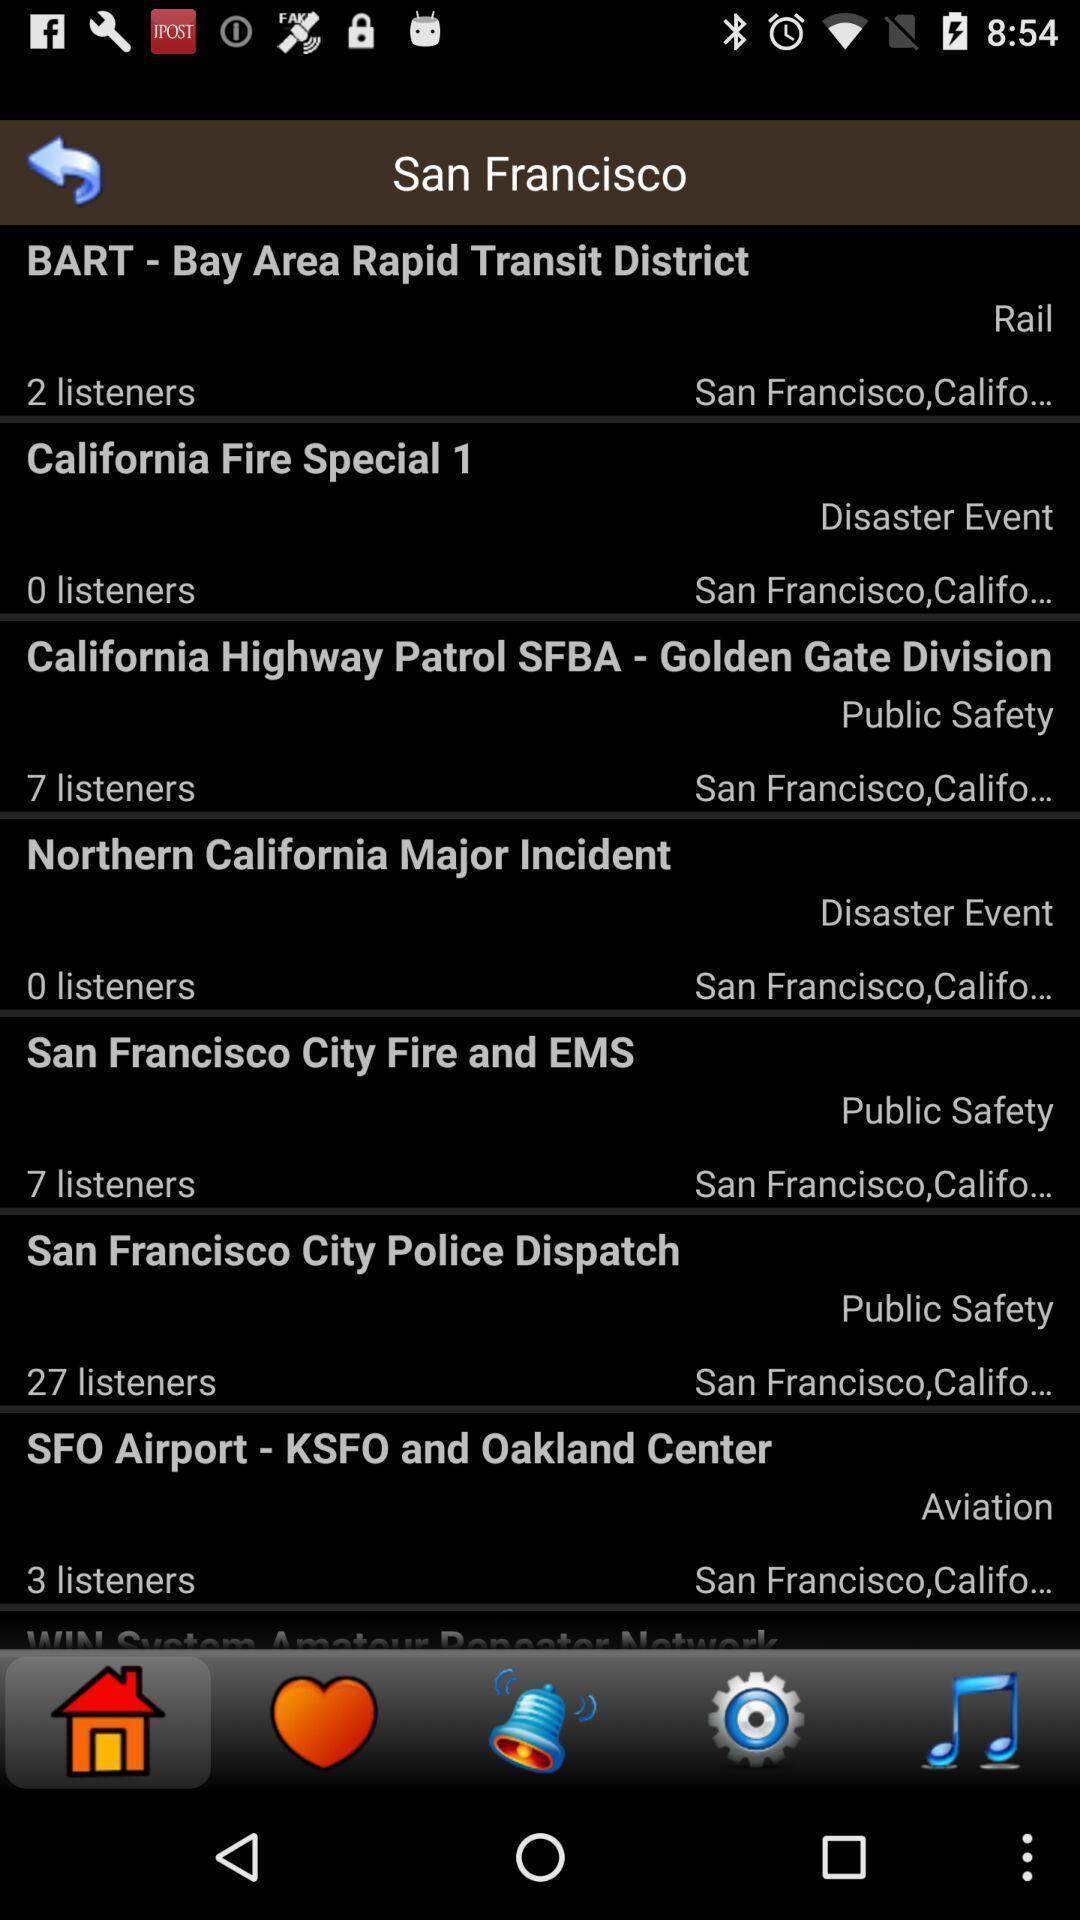Tell me what you see in this picture. Page displaying various articles. 